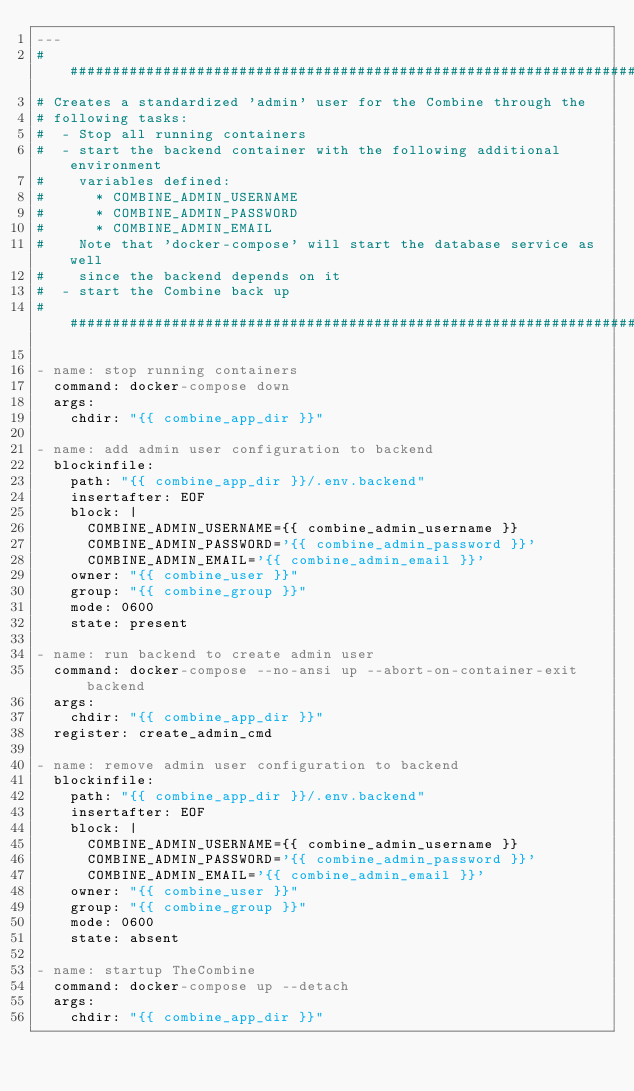Convert code to text. <code><loc_0><loc_0><loc_500><loc_500><_YAML_>---
#########################################################################
# Creates a standardized 'admin' user for the Combine through the
# following tasks:
#  - Stop all running containers
#  - start the backend container with the following additional environment
#    variables defined:
#      * COMBINE_ADMIN_USERNAME
#      * COMBINE_ADMIN_PASSWORD
#      * COMBINE_ADMIN_EMAIL
#    Note that 'docker-compose' will start the database service as well
#    since the backend depends on it
#  - start the Combine back up
#########################################################################

- name: stop running containers
  command: docker-compose down
  args:
    chdir: "{{ combine_app_dir }}"

- name: add admin user configuration to backend
  blockinfile:
    path: "{{ combine_app_dir }}/.env.backend"
    insertafter: EOF
    block: |
      COMBINE_ADMIN_USERNAME={{ combine_admin_username }}
      COMBINE_ADMIN_PASSWORD='{{ combine_admin_password }}'
      COMBINE_ADMIN_EMAIL='{{ combine_admin_email }}'
    owner: "{{ combine_user }}"
    group: "{{ combine_group }}"
    mode: 0600
    state: present

- name: run backend to create admin user
  command: docker-compose --no-ansi up --abort-on-container-exit  backend
  args:
    chdir: "{{ combine_app_dir }}"
  register: create_admin_cmd

- name: remove admin user configuration to backend
  blockinfile:
    path: "{{ combine_app_dir }}/.env.backend"
    insertafter: EOF
    block: |
      COMBINE_ADMIN_USERNAME={{ combine_admin_username }}
      COMBINE_ADMIN_PASSWORD='{{ combine_admin_password }}'
      COMBINE_ADMIN_EMAIL='{{ combine_admin_email }}'
    owner: "{{ combine_user }}"
    group: "{{ combine_group }}"
    mode: 0600
    state: absent

- name: startup TheCombine
  command: docker-compose up --detach
  args:
    chdir: "{{ combine_app_dir }}"
</code> 